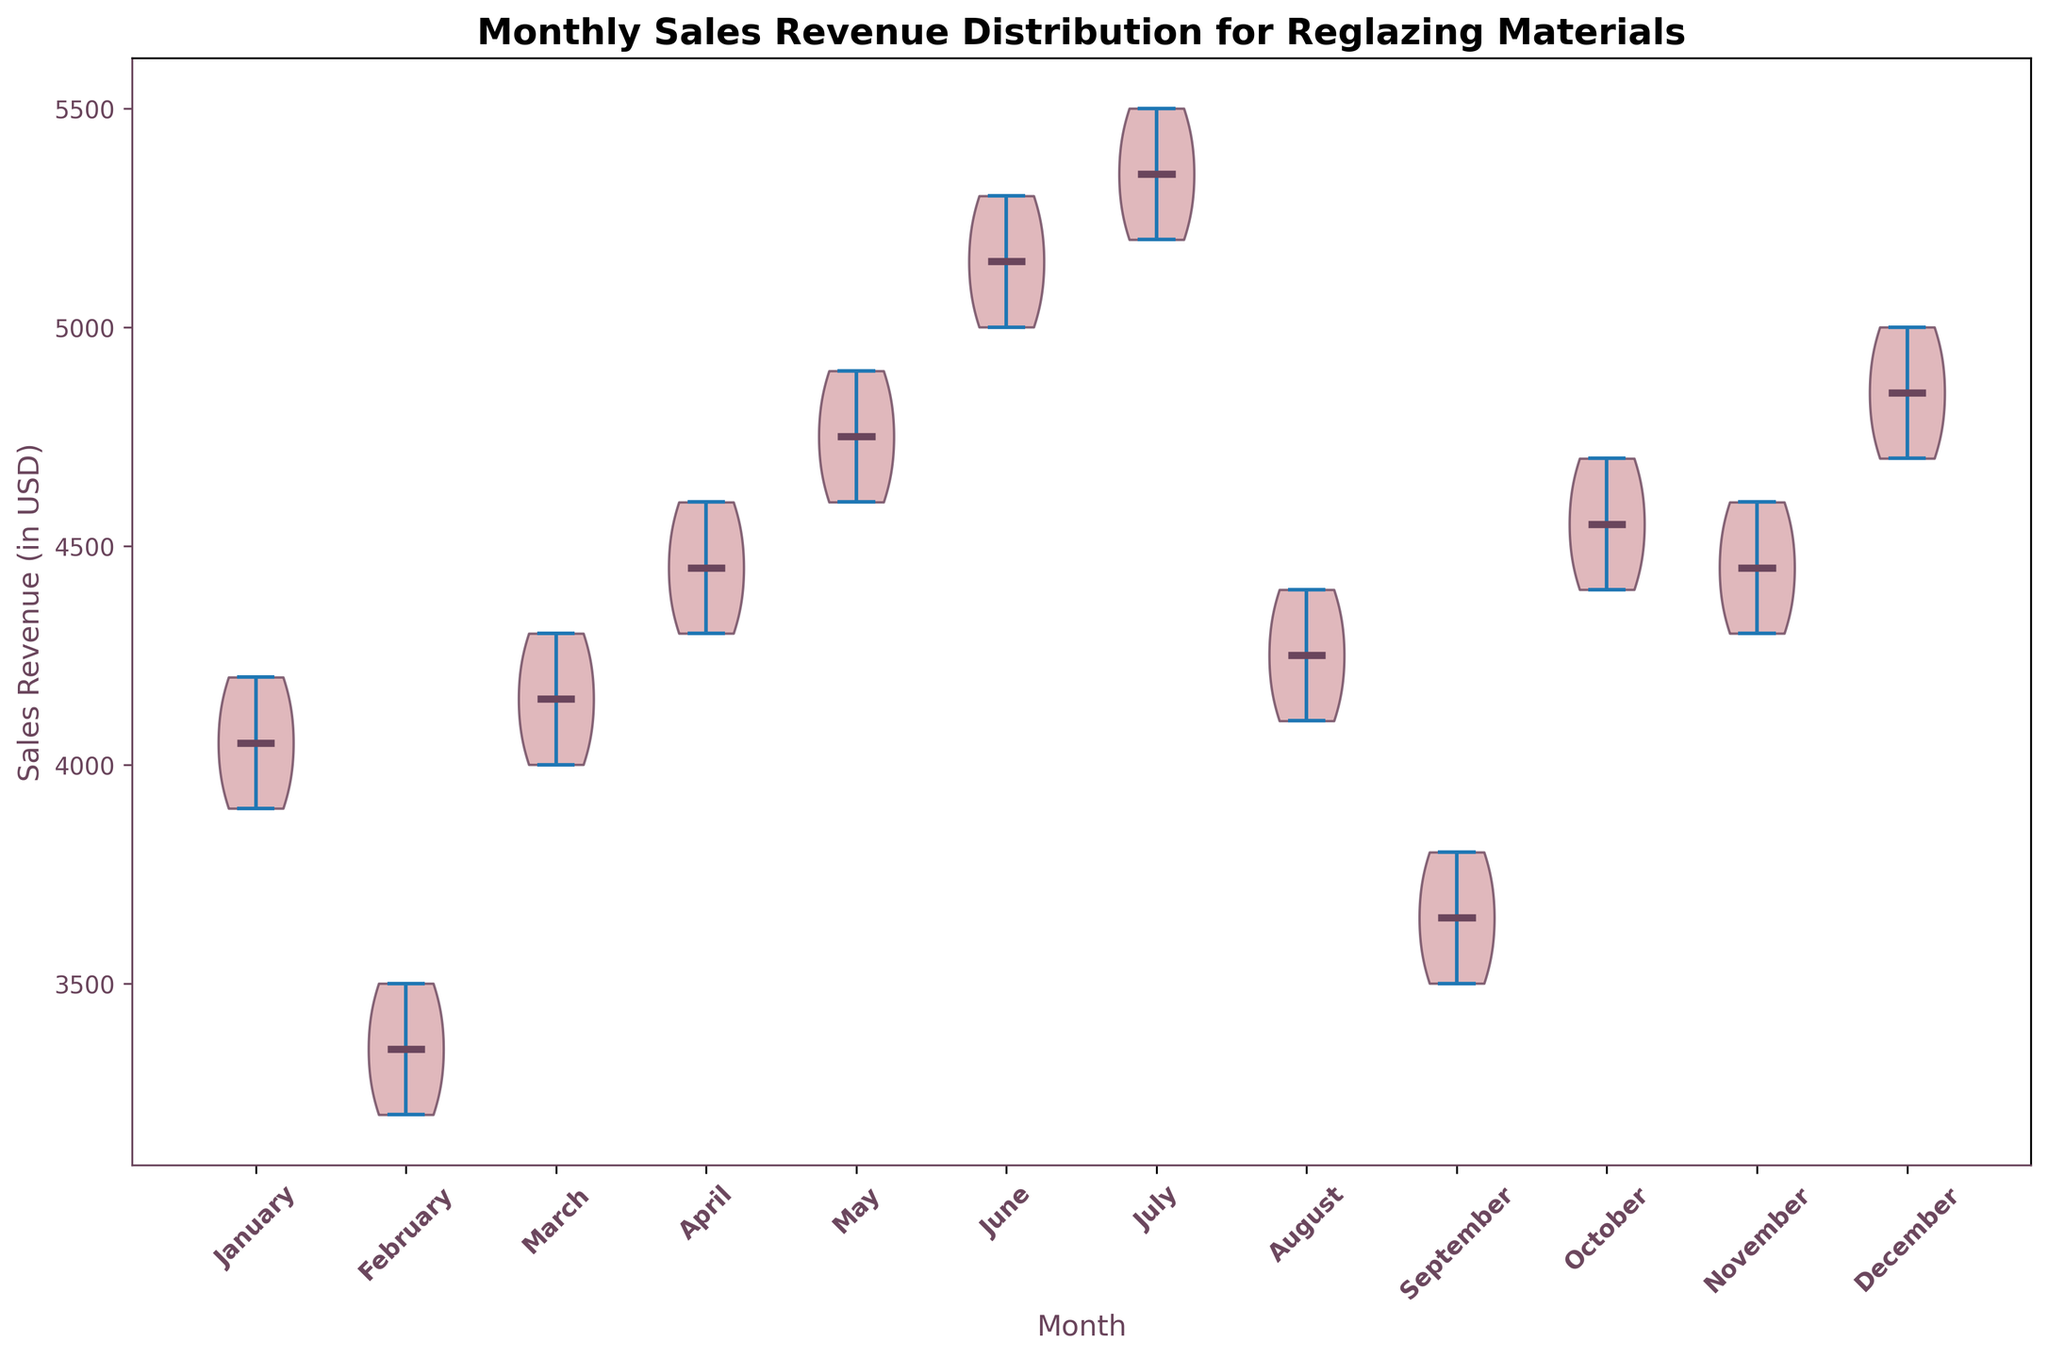What is the median sales revenue for May? Look at the distribution for the month of May. The median is depicted by the white line inside the violin plot. This is approximately at the $4800 mark based on the plot.
Answer: $4800 Which month has the highest median sales revenue? Review all the months' median lines. June's median appears to be higher than all other months at around $5150.
Answer: June How does the spread of sales revenue in February compare to that in July? Examine the width and shape of the violin plots for February and July. February’s spread is much narrower, indicating less variability in sales revenue, while July's spread is wider, indicating more variability.
Answer: February has a narrower spread Which months have a median sales revenue greater than $4500? Identify the months where the median line is above $4500. These months appear to be May, June, and July.
Answer: May, June, and July What is the interquartile range (IQR) for January’s sales revenue? The IQR is the distance between the 25th and 75th percentiles of the distribution. From the plot, January’s IQR spans from around $4000 to $4125, so the IQR would be $4125 - $4000 = $125.
Answer: $125 Which month has the most uniform distribution of sales revenue? Look for the month where the violin plot has the most symmetrical and consistent thickness. October appears to have the most uniform distribution.
Answer: October Compare the median sales revenues between March and October. March’s median is around $4150, and October’s median is around $4550. Therefore, October’s median is higher than March’s median by about $400.
Answer: October’s median is higher What is the range of sales revenue in November? Identify the minimum and maximum values for the month of November. The range appears to be from $4300 to $4600. Thus, the range is $4600 - $4300 = $300.
Answer: $300 